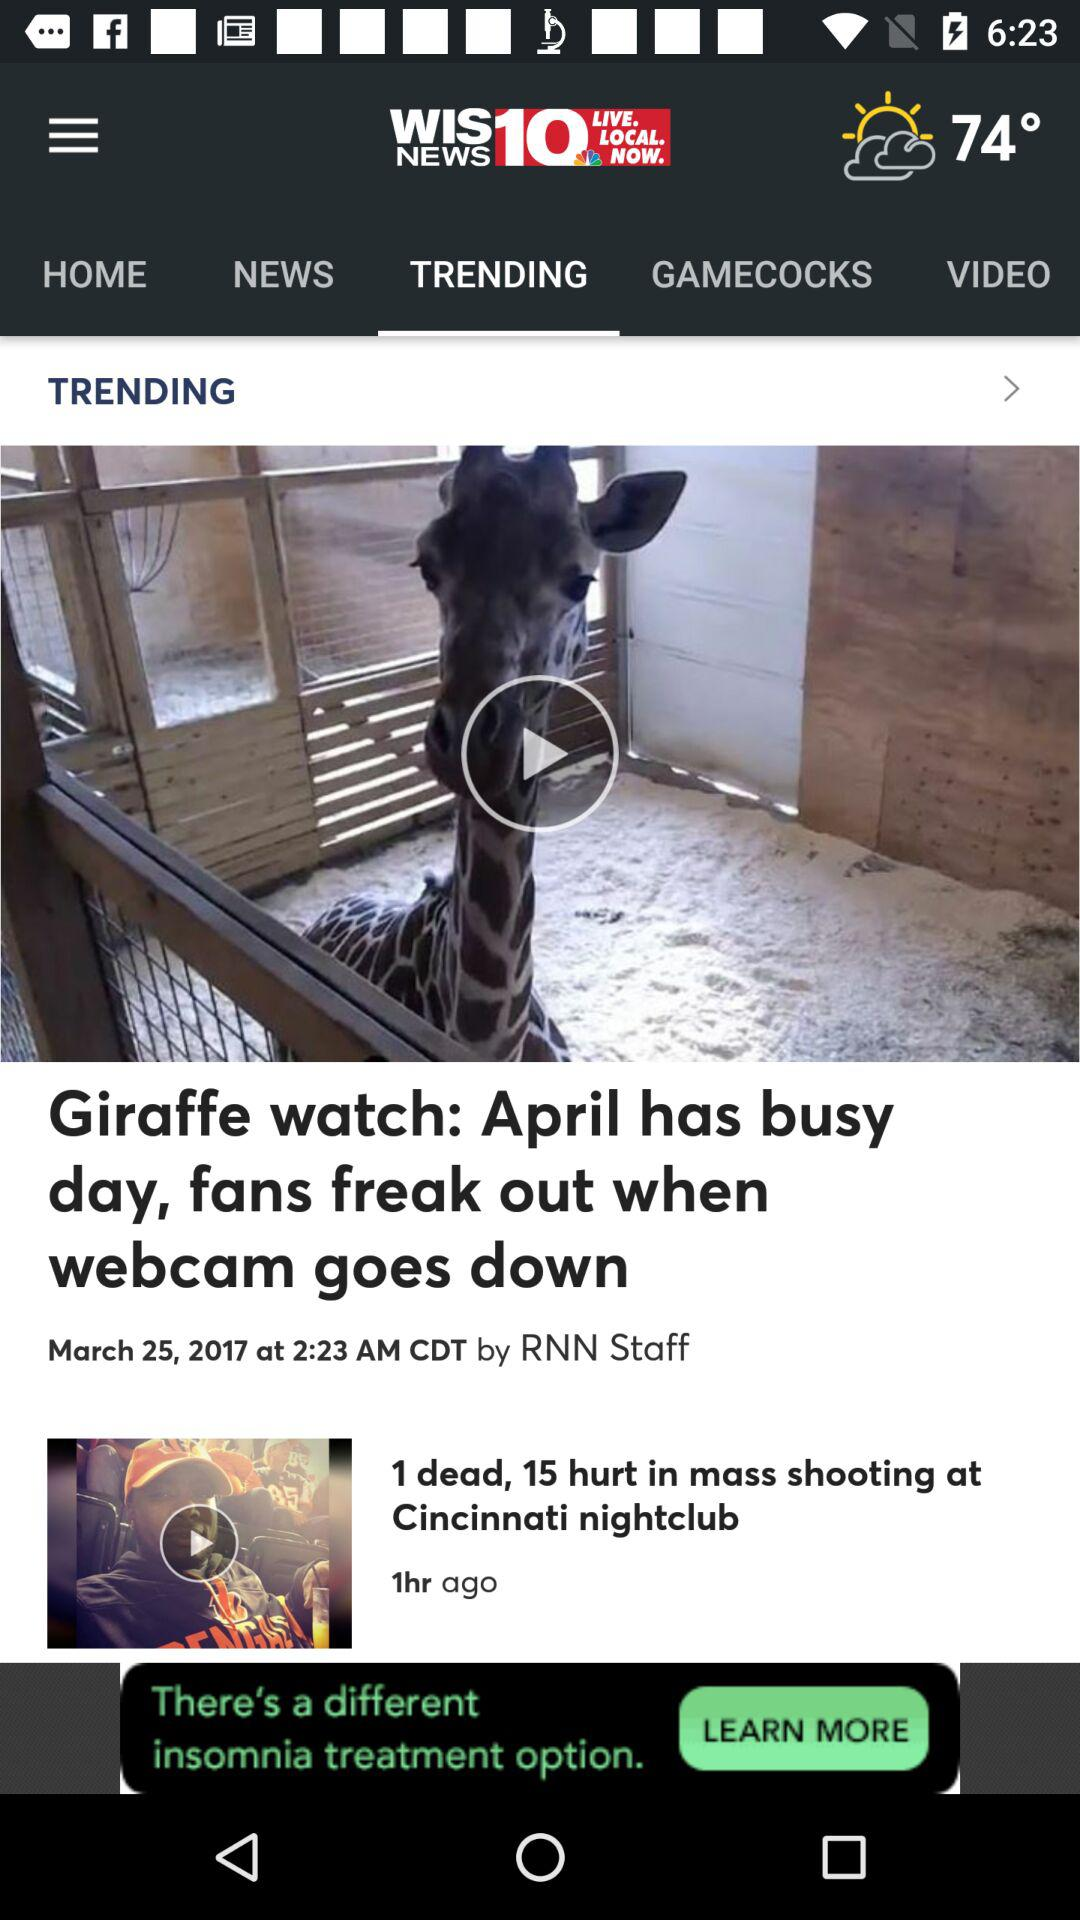Who is the author of "Giraffe watch: April has busy day, fans freak out when webcam goes down" article? The author of the article is RNN Staff. 